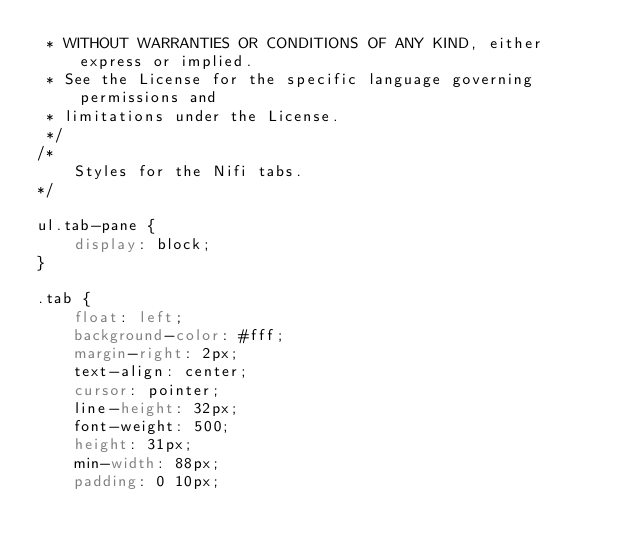<code> <loc_0><loc_0><loc_500><loc_500><_CSS_> * WITHOUT WARRANTIES OR CONDITIONS OF ANY KIND, either express or implied.
 * See the License for the specific language governing permissions and
 * limitations under the License.
 */
/*
    Styles for the Nifi tabs.
*/

ul.tab-pane {
    display: block;
}

.tab {
    float: left;
    background-color: #fff;
    margin-right: 2px;
    text-align: center;
    cursor: pointer;
    line-height: 32px;
    font-weight: 500;
    height: 31px;
    min-width: 88px;
    padding: 0 10px;</code> 